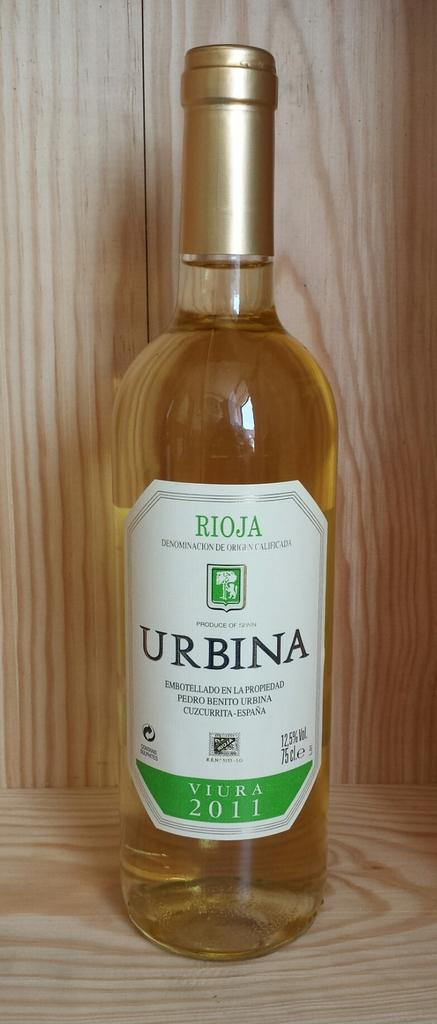<image>
Create a compact narrative representing the image presented. A clear unopened bottle of Urbina from 2011. 